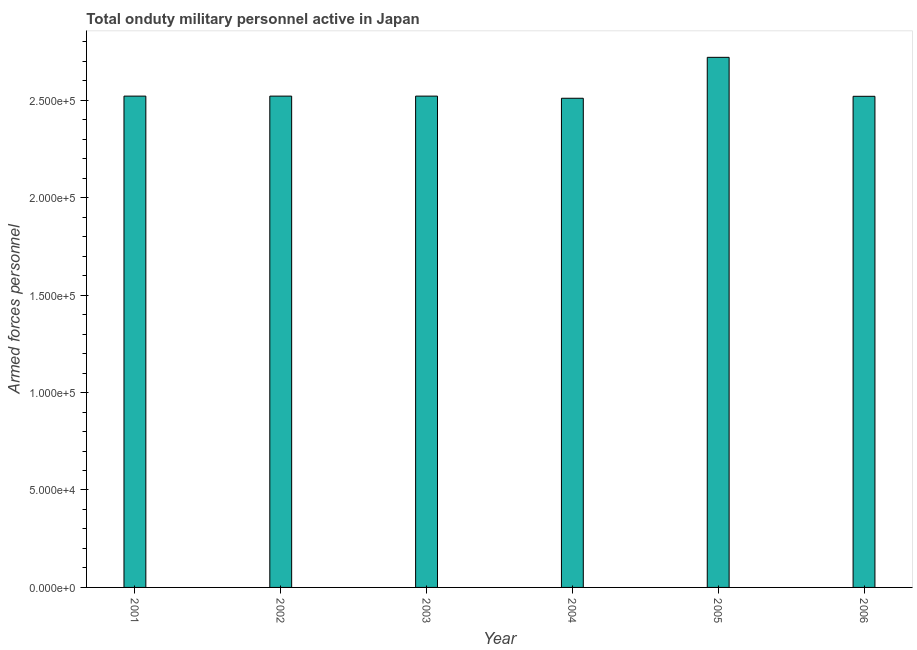Does the graph contain grids?
Offer a very short reply. No. What is the title of the graph?
Give a very brief answer. Total onduty military personnel active in Japan. What is the label or title of the Y-axis?
Keep it short and to the point. Armed forces personnel. What is the number of armed forces personnel in 2003?
Offer a very short reply. 2.52e+05. Across all years, what is the maximum number of armed forces personnel?
Offer a very short reply. 2.72e+05. Across all years, what is the minimum number of armed forces personnel?
Your response must be concise. 2.51e+05. In which year was the number of armed forces personnel minimum?
Provide a succinct answer. 2004. What is the sum of the number of armed forces personnel?
Keep it short and to the point. 1.53e+06. What is the average number of armed forces personnel per year?
Provide a short and direct response. 2.55e+05. What is the median number of armed forces personnel?
Offer a very short reply. 2.52e+05. What is the ratio of the number of armed forces personnel in 2003 to that in 2006?
Make the answer very short. 1. Is the number of armed forces personnel in 2002 less than that in 2004?
Your response must be concise. No. Is the difference between the number of armed forces personnel in 2004 and 2006 greater than the difference between any two years?
Give a very brief answer. No. What is the difference between the highest and the second highest number of armed forces personnel?
Provide a short and direct response. 1.99e+04. Is the sum of the number of armed forces personnel in 2004 and 2006 greater than the maximum number of armed forces personnel across all years?
Ensure brevity in your answer.  Yes. What is the difference between the highest and the lowest number of armed forces personnel?
Provide a short and direct response. 2.10e+04. How many bars are there?
Make the answer very short. 6. What is the difference between two consecutive major ticks on the Y-axis?
Keep it short and to the point. 5.00e+04. Are the values on the major ticks of Y-axis written in scientific E-notation?
Offer a very short reply. Yes. What is the Armed forces personnel of 2001?
Give a very brief answer. 2.52e+05. What is the Armed forces personnel of 2002?
Offer a very short reply. 2.52e+05. What is the Armed forces personnel in 2003?
Offer a terse response. 2.52e+05. What is the Armed forces personnel in 2004?
Your response must be concise. 2.51e+05. What is the Armed forces personnel in 2005?
Offer a very short reply. 2.72e+05. What is the Armed forces personnel of 2006?
Your answer should be compact. 2.52e+05. What is the difference between the Armed forces personnel in 2001 and 2003?
Ensure brevity in your answer.  0. What is the difference between the Armed forces personnel in 2001 and 2004?
Your answer should be very brief. 1100. What is the difference between the Armed forces personnel in 2001 and 2005?
Ensure brevity in your answer.  -1.99e+04. What is the difference between the Armed forces personnel in 2002 and 2004?
Ensure brevity in your answer.  1100. What is the difference between the Armed forces personnel in 2002 and 2005?
Your answer should be compact. -1.99e+04. What is the difference between the Armed forces personnel in 2003 and 2004?
Ensure brevity in your answer.  1100. What is the difference between the Armed forces personnel in 2003 and 2005?
Make the answer very short. -1.99e+04. What is the difference between the Armed forces personnel in 2003 and 2006?
Your answer should be very brief. 100. What is the difference between the Armed forces personnel in 2004 and 2005?
Provide a succinct answer. -2.10e+04. What is the difference between the Armed forces personnel in 2004 and 2006?
Your answer should be very brief. -1000. What is the ratio of the Armed forces personnel in 2001 to that in 2002?
Give a very brief answer. 1. What is the ratio of the Armed forces personnel in 2001 to that in 2004?
Make the answer very short. 1. What is the ratio of the Armed forces personnel in 2001 to that in 2005?
Provide a succinct answer. 0.93. What is the ratio of the Armed forces personnel in 2002 to that in 2003?
Provide a succinct answer. 1. What is the ratio of the Armed forces personnel in 2002 to that in 2005?
Keep it short and to the point. 0.93. What is the ratio of the Armed forces personnel in 2002 to that in 2006?
Give a very brief answer. 1. What is the ratio of the Armed forces personnel in 2003 to that in 2005?
Offer a very short reply. 0.93. What is the ratio of the Armed forces personnel in 2004 to that in 2005?
Keep it short and to the point. 0.92. What is the ratio of the Armed forces personnel in 2004 to that in 2006?
Your response must be concise. 1. What is the ratio of the Armed forces personnel in 2005 to that in 2006?
Make the answer very short. 1.08. 